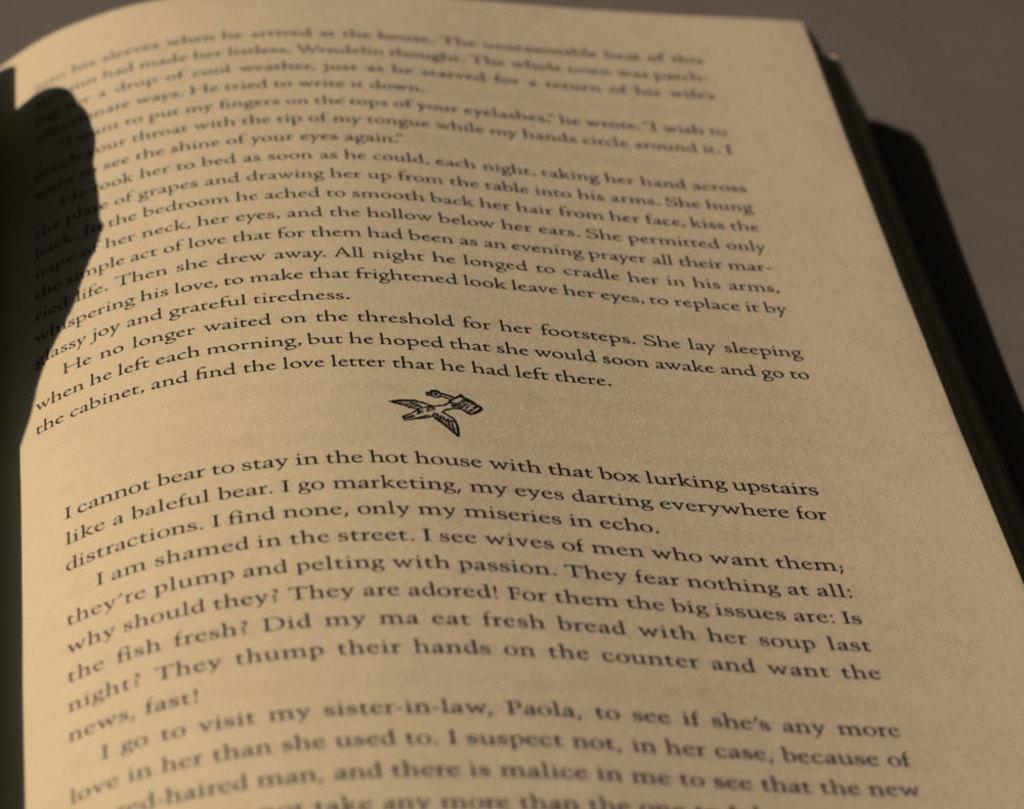<image>
Give a short and clear explanation of the subsequent image. a page from a book that one cannot stand to stay on a hot house 